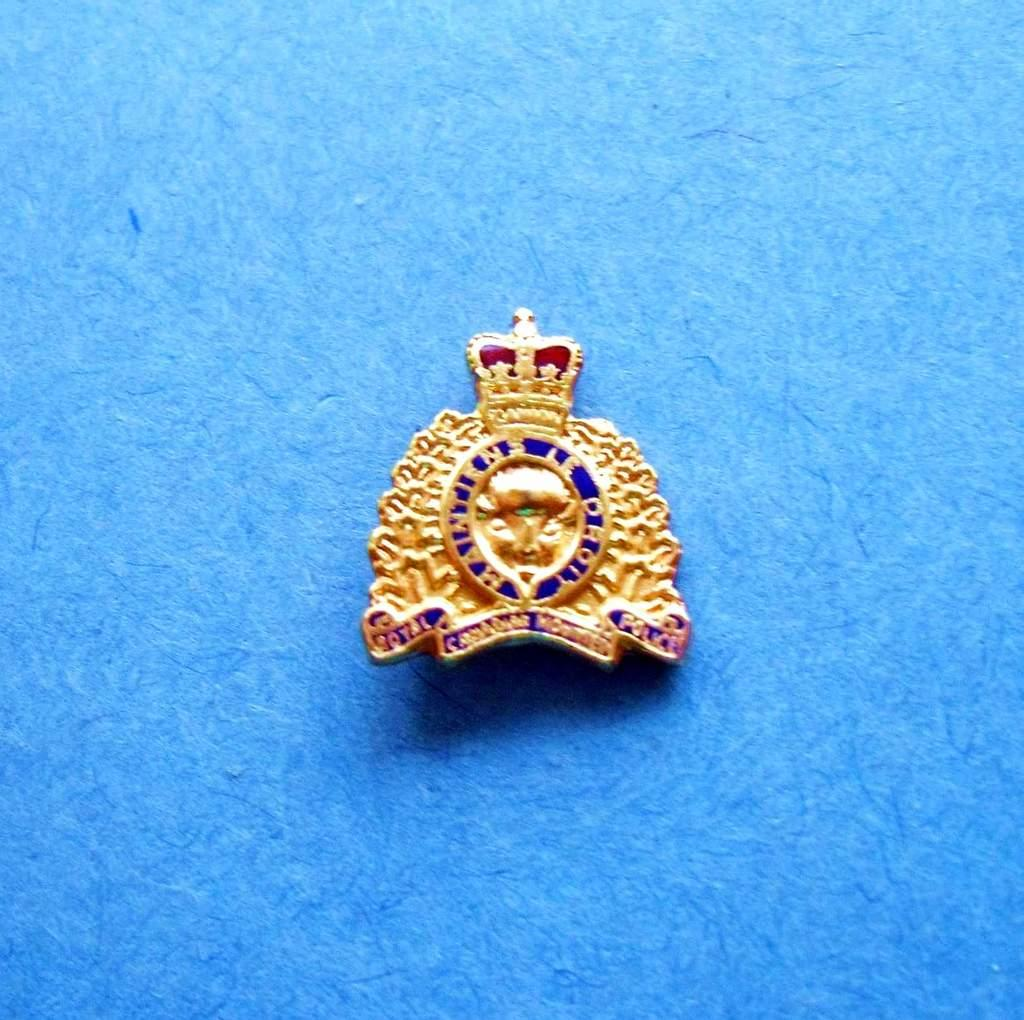What is the main subject in the image? There is an emblem in the image. Can you describe the placement of the emblem in the image? The emblem is placed on a surface. What type of fruit is hanging from the emblem in the image? There is no fruit present in the image, and therefore no such activity can be observed. 